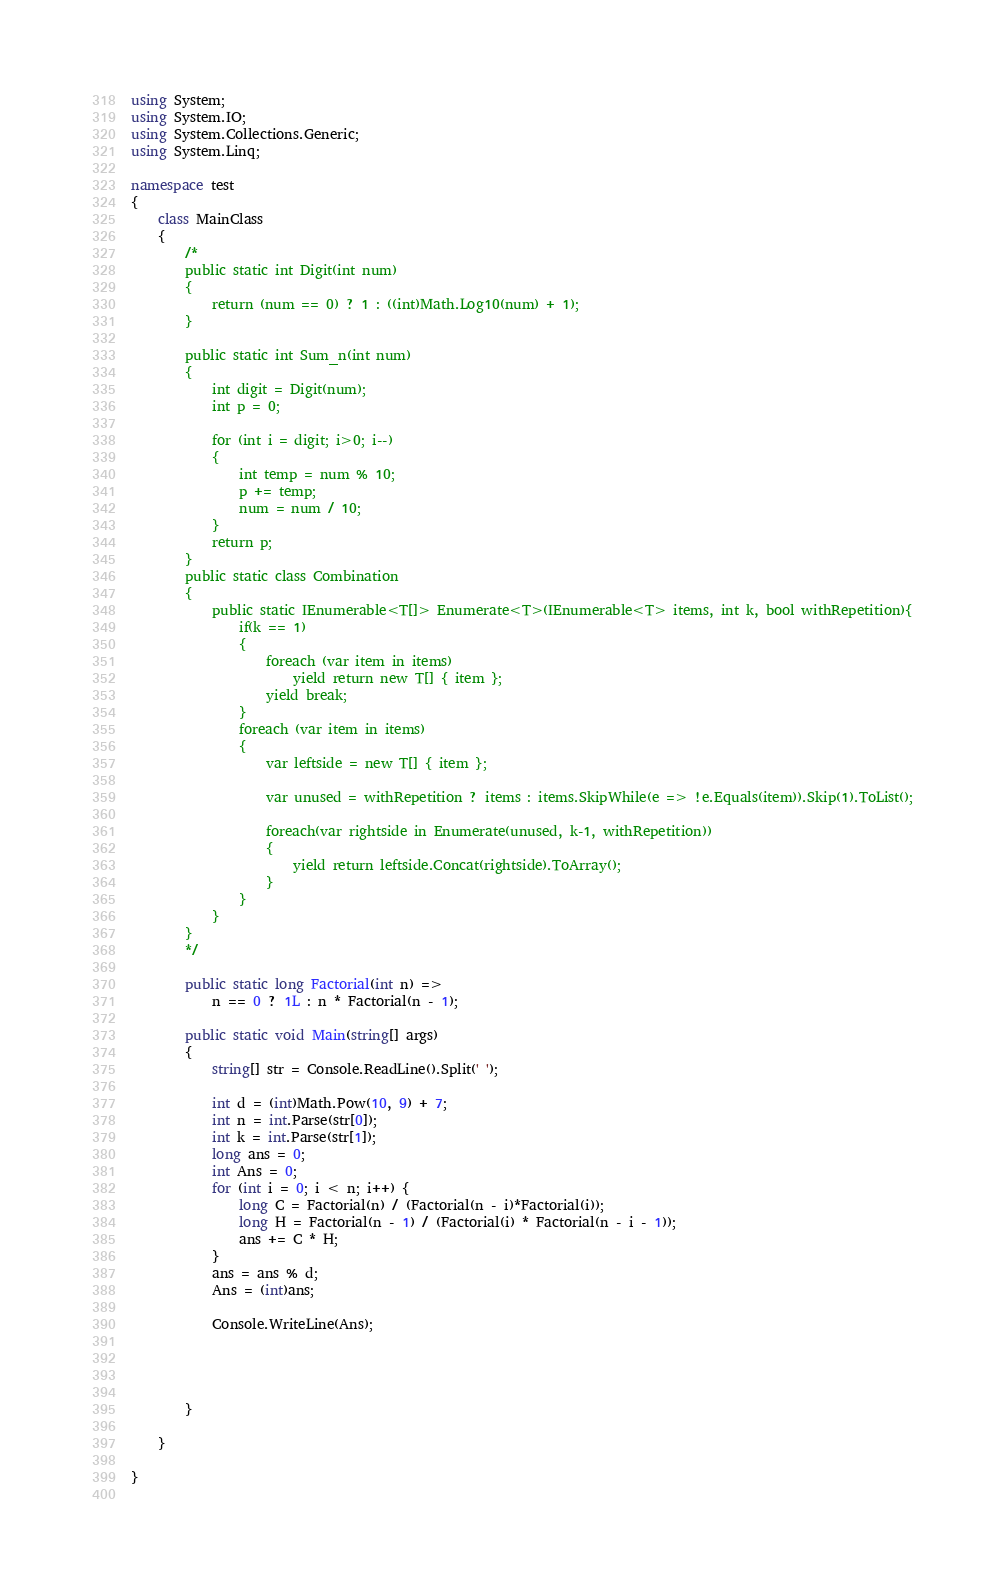<code> <loc_0><loc_0><loc_500><loc_500><_C#_>using System;
using System.IO;
using System.Collections.Generic;
using System.Linq;

namespace test
{
    class MainClass
    {
        /*
        public static int Digit(int num)
        {
            return (num == 0) ? 1 : ((int)Math.Log10(num) + 1);
        }

        public static int Sum_n(int num)
        {
            int digit = Digit(num);
            int p = 0;
            
            for (int i = digit; i>0; i--)
            {
                int temp = num % 10;
                p += temp;
                num = num / 10;
            }
            return p;
        }
        public static class Combination
        {
            public static IEnumerable<T[]> Enumerate<T>(IEnumerable<T> items, int k, bool withRepetition){
                if(k == 1)
                {
                    foreach (var item in items)
                        yield return new T[] { item };
                    yield break;
                }
                foreach (var item in items)
                {
                    var leftside = new T[] { item };

                    var unused = withRepetition ? items : items.SkipWhile(e => !e.Equals(item)).Skip(1).ToList();

                    foreach(var rightside in Enumerate(unused, k-1, withRepetition))
                    {
                        yield return leftside.Concat(rightside).ToArray();
                    }
                }
            } 
        }
        */

        public static long Factorial(int n) =>
            n == 0 ? 1L : n * Factorial(n - 1);

        public static void Main(string[] args)
        { 
            string[] str = Console.ReadLine().Split(' ');
            
            int d = (int)Math.Pow(10, 9) + 7;
            int n = int.Parse(str[0]);
            int k = int.Parse(str[1]);
            long ans = 0;
            int Ans = 0;
            for (int i = 0; i < n; i++) {
                long C = Factorial(n) / (Factorial(n - i)*Factorial(i));
                long H = Factorial(n - 1) / (Factorial(i) * Factorial(n - i - 1));
                ans += C * H;
            }
            ans = ans % d;
            Ans = (int)ans;

            Console.WriteLine(Ans);
            
            


        }

    }

}
    </code> 